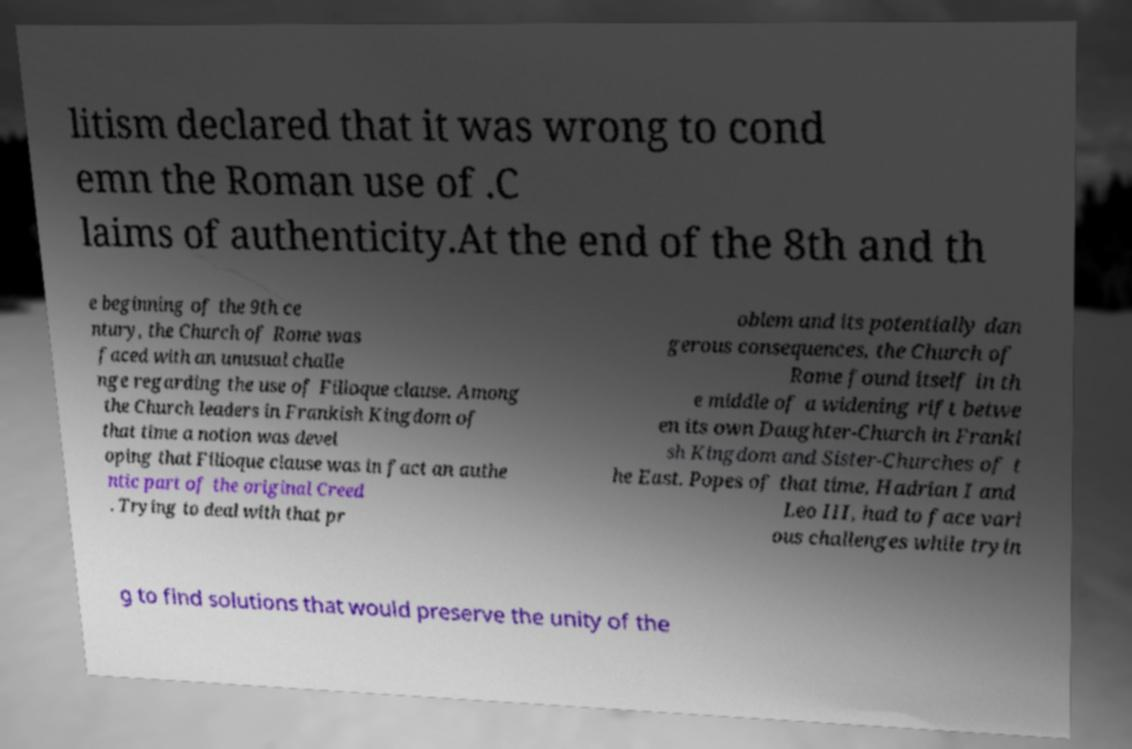Please identify and transcribe the text found in this image. litism declared that it was wrong to cond emn the Roman use of .C laims of authenticity.At the end of the 8th and th e beginning of the 9th ce ntury, the Church of Rome was faced with an unusual challe nge regarding the use of Filioque clause. Among the Church leaders in Frankish Kingdom of that time a notion was devel oping that Filioque clause was in fact an authe ntic part of the original Creed . Trying to deal with that pr oblem and its potentially dan gerous consequences, the Church of Rome found itself in th e middle of a widening rift betwe en its own Daughter-Church in Franki sh Kingdom and Sister-Churches of t he East. Popes of that time, Hadrian I and Leo III, had to face vari ous challenges while tryin g to find solutions that would preserve the unity of the 